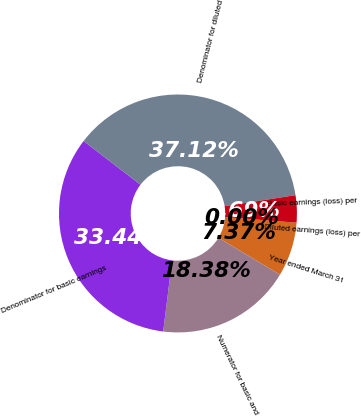Convert chart. <chart><loc_0><loc_0><loc_500><loc_500><pie_chart><fcel>Year ended March 31<fcel>Numerator for basic and<fcel>Denominator for basic earnings<fcel>Denominator for diluted<fcel>Basic earnings (loss) per<fcel>Diluted earnings (loss) per<nl><fcel>7.37%<fcel>18.38%<fcel>33.44%<fcel>37.12%<fcel>3.69%<fcel>0.0%<nl></chart> 